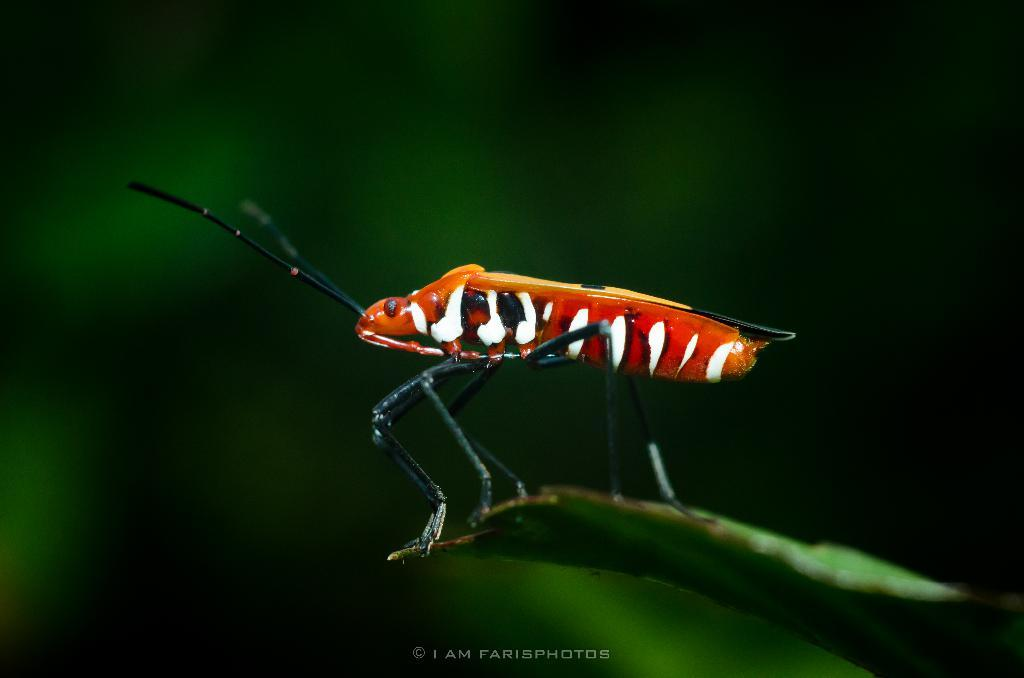What is the main subject of the image? There is an insect on a leaf in the image. Can you describe the background of the image? The background of the image is blurry. Is there any text present in the image? Yes, there is some text visible at the bottom of the image. What type of haircut does the insect's mom prefer for her child? There is no information about the insect's mom or haircuts in the image, so it cannot be determined from the image. 